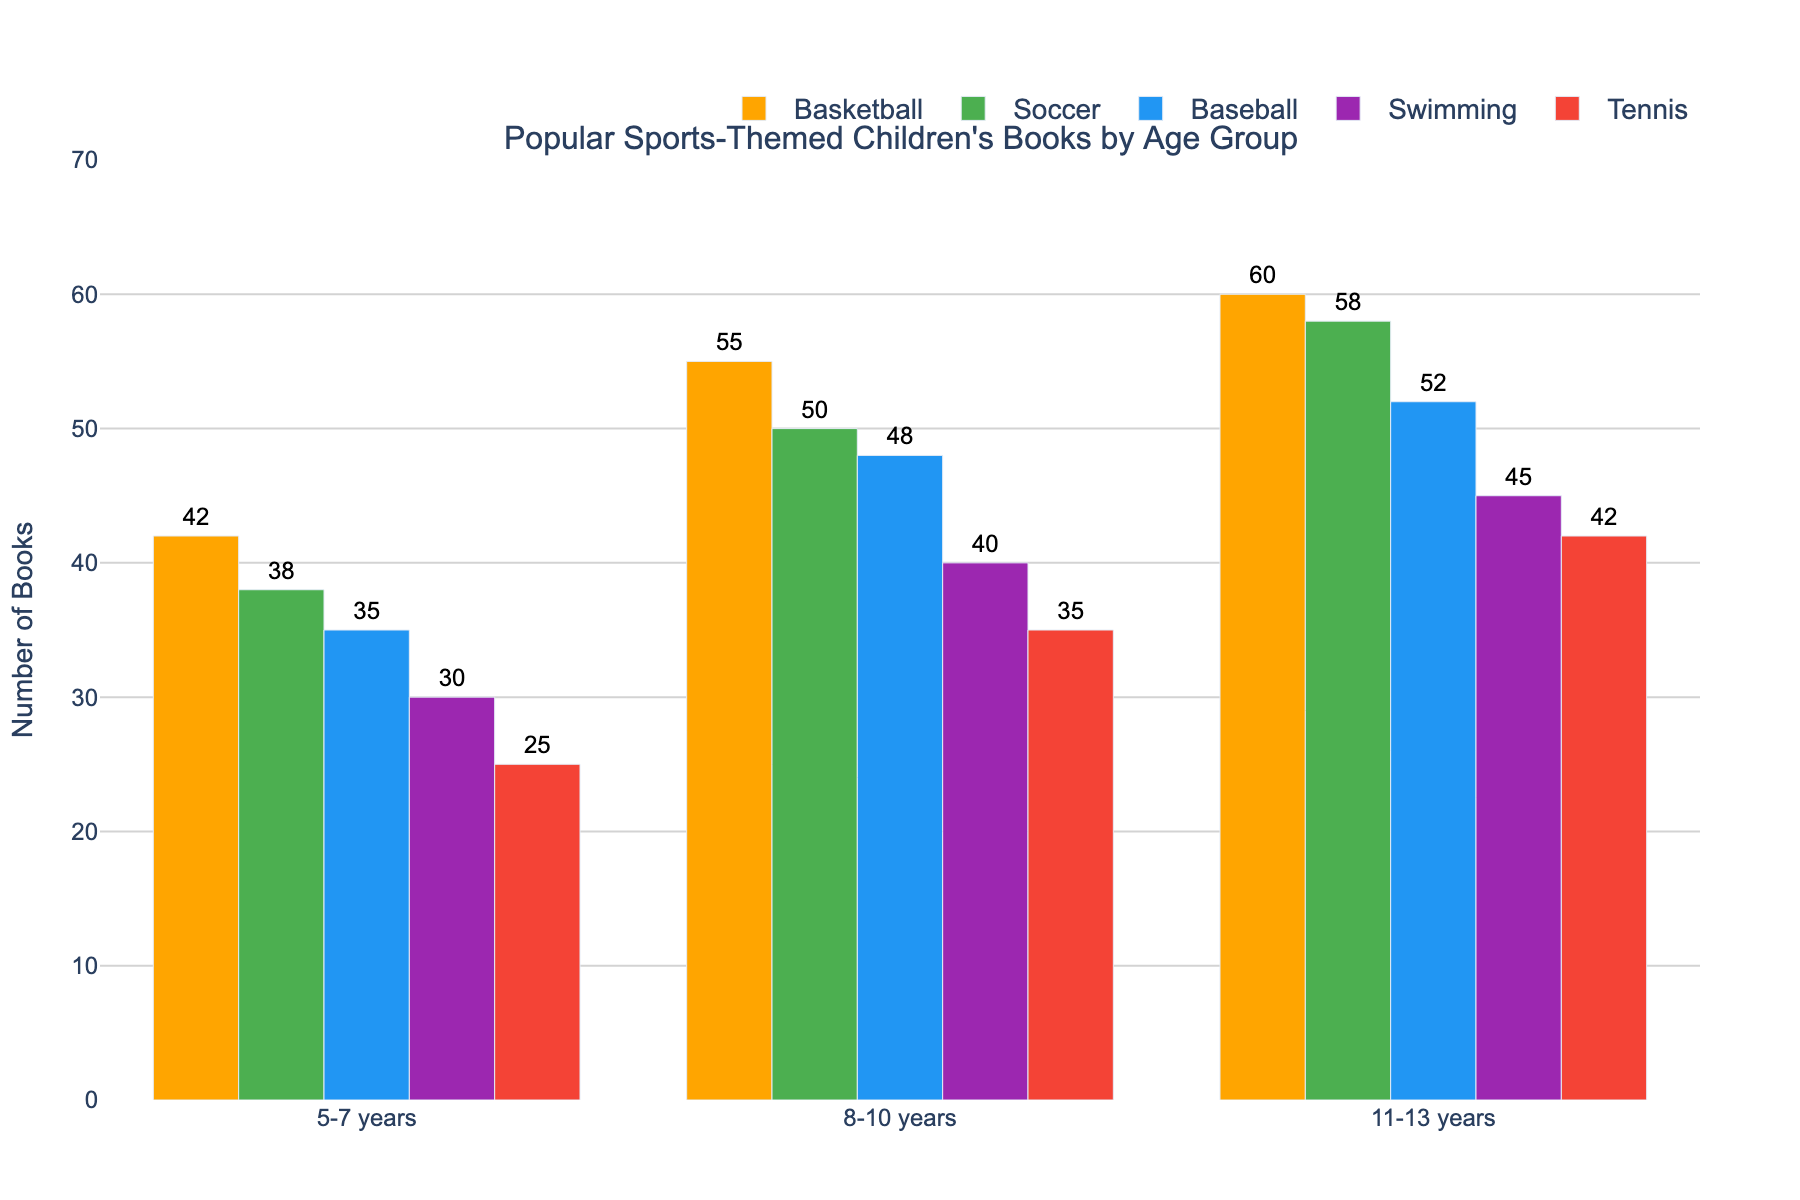What's the most popular sports-themed book genre for children aged 8-10 years? The bar chart shows various sports-themed books by age group. For children aged 8-10 years, Basketball has the highest bar, indicating that it is the most popular genre.
Answer: Basketball How many more baseball-themed books are there for children aged 11-13 years compared to those aged 5-7 years? In the bar chart, there are 52 baseball-themed books for 11-13 years and 35 for 5-7 years. The difference is 52 - 35.
Answer: 17 Which sport has the least popular-themed books for children aged 5-7 years? The shortest bar for the 5-7 years age group corresponds to Tennis.
Answer: Tennis What's the total number of soccer-themed books across all age groups? Summing the number of soccer-themed books for each age group (5-7 years: 38, 8-10 years: 50, 11-13 years: 58), we get 38 + 50 + 58.
Answer: 146 In which age group are tennis-themed books more popular: 8-10 years or 11-13 years? Comparing the heights of the bars for Tennis, the bar is higher for the 11-13 years group than for the 8-10 years group.
Answer: 11-13 years Which sport shows a trend of increasing popularity with age? The bars for Basketball increase from 42 (5-7 years), to 55 (8-10 years), to 60 (11-13 years), indicating an increasing popularity with age.
Answer: Basketball How many total books are there for the 8-10 years age group across all sports? Adding the number of books for each sport (Basketball: 55, Soccer: 50, Baseball: 48, Swimming: 40, Tennis: 35) for 8-10 years, we get 55 + 50 + 48 + 40 + 35.
Answer: 228 Which sport has the closest number of themed books for children aged 5-7 years and 8-10 years? Looking at the bars' heights, Baseball has 35 books for 5-7 years and 48 books for 8-10 years, which are relatively close compared to other sports.
Answer: Baseball What is the difference between the least and the most popular sports-themed books for children aged 11-13 years? For 11-13 years, the least popular is Swimming with 45 books, and the most popular is Basketball with 60 books. The difference is 60 - 45.
Answer: 15 